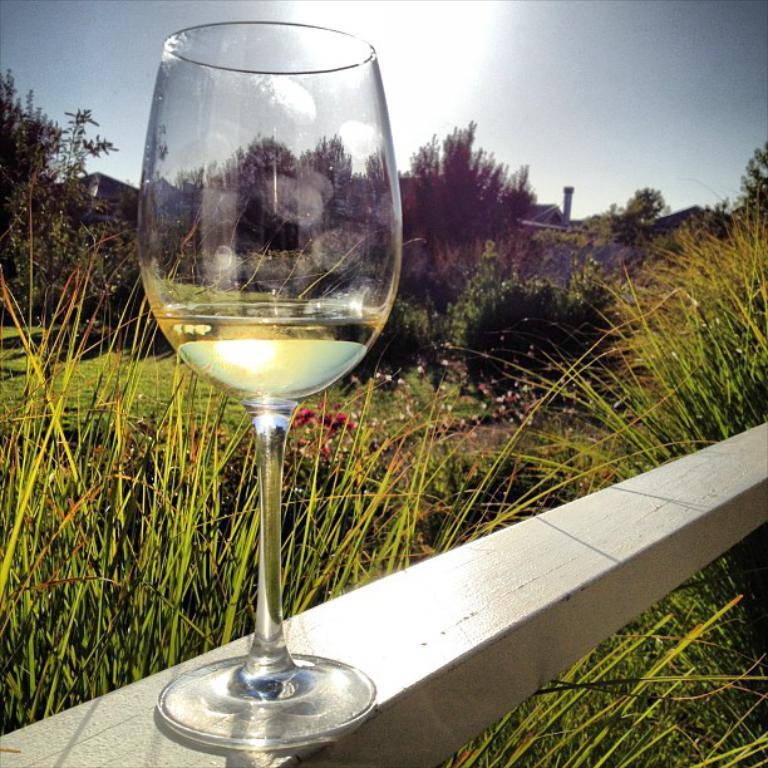How would you summarize this image in a sentence or two? In this image I can see a glass. In the background I can see plants, grass, number of trees, a building and the sky. 